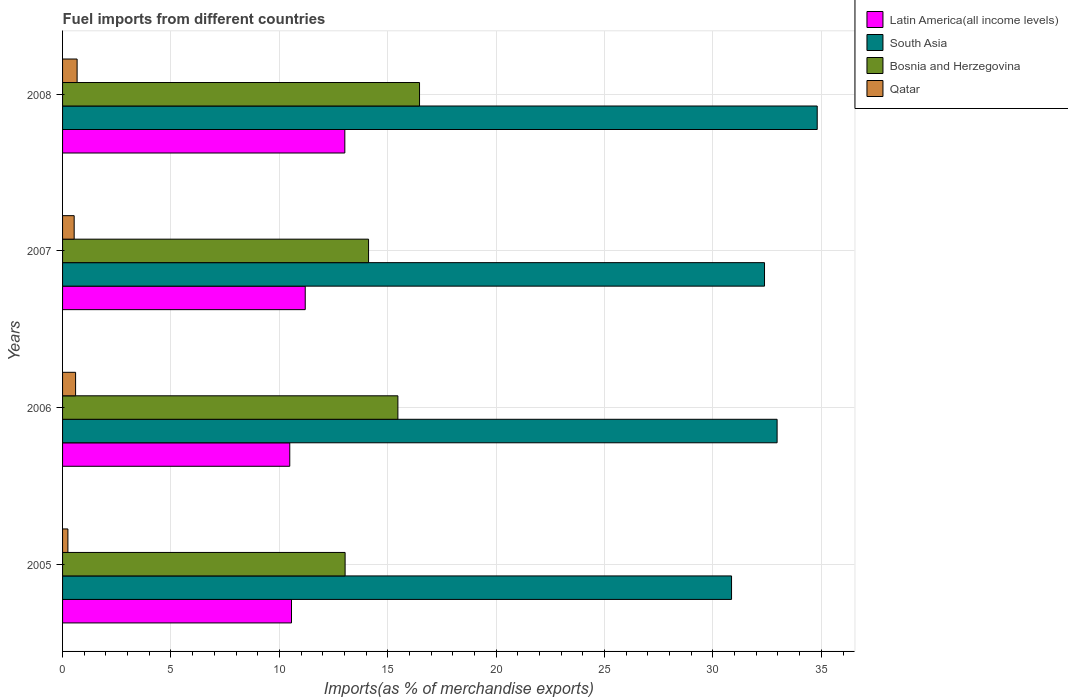Are the number of bars per tick equal to the number of legend labels?
Ensure brevity in your answer.  Yes. How many bars are there on the 3rd tick from the bottom?
Offer a very short reply. 4. What is the label of the 4th group of bars from the top?
Keep it short and to the point. 2005. What is the percentage of imports to different countries in South Asia in 2007?
Provide a short and direct response. 32.38. Across all years, what is the maximum percentage of imports to different countries in Bosnia and Herzegovina?
Your answer should be compact. 16.47. Across all years, what is the minimum percentage of imports to different countries in Qatar?
Offer a terse response. 0.25. In which year was the percentage of imports to different countries in Qatar maximum?
Provide a short and direct response. 2008. In which year was the percentage of imports to different countries in Qatar minimum?
Ensure brevity in your answer.  2005. What is the total percentage of imports to different countries in Latin America(all income levels) in the graph?
Give a very brief answer. 45.25. What is the difference between the percentage of imports to different countries in Qatar in 2005 and that in 2008?
Give a very brief answer. -0.42. What is the difference between the percentage of imports to different countries in South Asia in 2006 and the percentage of imports to different countries in Latin America(all income levels) in 2008?
Your answer should be compact. 19.94. What is the average percentage of imports to different countries in Latin America(all income levels) per year?
Offer a very short reply. 11.31. In the year 2006, what is the difference between the percentage of imports to different countries in South Asia and percentage of imports to different countries in Latin America(all income levels)?
Make the answer very short. 22.48. In how many years, is the percentage of imports to different countries in Latin America(all income levels) greater than 8 %?
Your response must be concise. 4. What is the ratio of the percentage of imports to different countries in Qatar in 2005 to that in 2007?
Provide a short and direct response. 0.46. Is the percentage of imports to different countries in Qatar in 2006 less than that in 2008?
Make the answer very short. Yes. What is the difference between the highest and the second highest percentage of imports to different countries in South Asia?
Offer a terse response. 1.85. What is the difference between the highest and the lowest percentage of imports to different countries in Bosnia and Herzegovina?
Make the answer very short. 3.43. What does the 3rd bar from the top in 2007 represents?
Offer a very short reply. South Asia. What does the 1st bar from the bottom in 2007 represents?
Offer a very short reply. Latin America(all income levels). How many bars are there?
Provide a short and direct response. 16. How many years are there in the graph?
Keep it short and to the point. 4. What is the difference between two consecutive major ticks on the X-axis?
Your answer should be compact. 5. Does the graph contain any zero values?
Keep it short and to the point. No. Does the graph contain grids?
Offer a very short reply. Yes. What is the title of the graph?
Keep it short and to the point. Fuel imports from different countries. What is the label or title of the X-axis?
Give a very brief answer. Imports(as % of merchandise exports). What is the label or title of the Y-axis?
Give a very brief answer. Years. What is the Imports(as % of merchandise exports) of Latin America(all income levels) in 2005?
Your answer should be very brief. 10.56. What is the Imports(as % of merchandise exports) in South Asia in 2005?
Your response must be concise. 30.86. What is the Imports(as % of merchandise exports) in Bosnia and Herzegovina in 2005?
Make the answer very short. 13.03. What is the Imports(as % of merchandise exports) in Qatar in 2005?
Provide a short and direct response. 0.25. What is the Imports(as % of merchandise exports) of Latin America(all income levels) in 2006?
Offer a very short reply. 10.48. What is the Imports(as % of merchandise exports) in South Asia in 2006?
Ensure brevity in your answer.  32.96. What is the Imports(as % of merchandise exports) in Bosnia and Herzegovina in 2006?
Provide a short and direct response. 15.47. What is the Imports(as % of merchandise exports) in Qatar in 2006?
Ensure brevity in your answer.  0.6. What is the Imports(as % of merchandise exports) in Latin America(all income levels) in 2007?
Keep it short and to the point. 11.19. What is the Imports(as % of merchandise exports) of South Asia in 2007?
Offer a very short reply. 32.38. What is the Imports(as % of merchandise exports) of Bosnia and Herzegovina in 2007?
Your response must be concise. 14.11. What is the Imports(as % of merchandise exports) of Qatar in 2007?
Make the answer very short. 0.54. What is the Imports(as % of merchandise exports) of Latin America(all income levels) in 2008?
Your response must be concise. 13.02. What is the Imports(as % of merchandise exports) in South Asia in 2008?
Provide a short and direct response. 34.81. What is the Imports(as % of merchandise exports) of Bosnia and Herzegovina in 2008?
Your answer should be very brief. 16.47. What is the Imports(as % of merchandise exports) of Qatar in 2008?
Your answer should be compact. 0.67. Across all years, what is the maximum Imports(as % of merchandise exports) in Latin America(all income levels)?
Provide a succinct answer. 13.02. Across all years, what is the maximum Imports(as % of merchandise exports) of South Asia?
Your answer should be very brief. 34.81. Across all years, what is the maximum Imports(as % of merchandise exports) of Bosnia and Herzegovina?
Provide a succinct answer. 16.47. Across all years, what is the maximum Imports(as % of merchandise exports) in Qatar?
Ensure brevity in your answer.  0.67. Across all years, what is the minimum Imports(as % of merchandise exports) of Latin America(all income levels)?
Your answer should be compact. 10.48. Across all years, what is the minimum Imports(as % of merchandise exports) in South Asia?
Keep it short and to the point. 30.86. Across all years, what is the minimum Imports(as % of merchandise exports) of Bosnia and Herzegovina?
Make the answer very short. 13.03. Across all years, what is the minimum Imports(as % of merchandise exports) of Qatar?
Your response must be concise. 0.25. What is the total Imports(as % of merchandise exports) of Latin America(all income levels) in the graph?
Make the answer very short. 45.25. What is the total Imports(as % of merchandise exports) of South Asia in the graph?
Offer a very short reply. 131.01. What is the total Imports(as % of merchandise exports) in Bosnia and Herzegovina in the graph?
Your answer should be compact. 59.08. What is the total Imports(as % of merchandise exports) of Qatar in the graph?
Your answer should be very brief. 2.05. What is the difference between the Imports(as % of merchandise exports) in South Asia in 2005 and that in 2006?
Your answer should be compact. -2.1. What is the difference between the Imports(as % of merchandise exports) of Bosnia and Herzegovina in 2005 and that in 2006?
Offer a terse response. -2.43. What is the difference between the Imports(as % of merchandise exports) in Qatar in 2005 and that in 2006?
Ensure brevity in your answer.  -0.35. What is the difference between the Imports(as % of merchandise exports) of Latin America(all income levels) in 2005 and that in 2007?
Your response must be concise. -0.63. What is the difference between the Imports(as % of merchandise exports) in South Asia in 2005 and that in 2007?
Keep it short and to the point. -1.52. What is the difference between the Imports(as % of merchandise exports) of Bosnia and Herzegovina in 2005 and that in 2007?
Provide a short and direct response. -1.08. What is the difference between the Imports(as % of merchandise exports) in Qatar in 2005 and that in 2007?
Your response must be concise. -0.29. What is the difference between the Imports(as % of merchandise exports) of Latin America(all income levels) in 2005 and that in 2008?
Provide a short and direct response. -2.46. What is the difference between the Imports(as % of merchandise exports) in South Asia in 2005 and that in 2008?
Ensure brevity in your answer.  -3.95. What is the difference between the Imports(as % of merchandise exports) in Bosnia and Herzegovina in 2005 and that in 2008?
Your response must be concise. -3.43. What is the difference between the Imports(as % of merchandise exports) in Qatar in 2005 and that in 2008?
Your response must be concise. -0.42. What is the difference between the Imports(as % of merchandise exports) of Latin America(all income levels) in 2006 and that in 2007?
Your answer should be compact. -0.71. What is the difference between the Imports(as % of merchandise exports) of South Asia in 2006 and that in 2007?
Your answer should be very brief. 0.58. What is the difference between the Imports(as % of merchandise exports) of Bosnia and Herzegovina in 2006 and that in 2007?
Offer a very short reply. 1.35. What is the difference between the Imports(as % of merchandise exports) of Qatar in 2006 and that in 2007?
Your answer should be compact. 0.07. What is the difference between the Imports(as % of merchandise exports) in Latin America(all income levels) in 2006 and that in 2008?
Your answer should be compact. -2.54. What is the difference between the Imports(as % of merchandise exports) in South Asia in 2006 and that in 2008?
Keep it short and to the point. -1.85. What is the difference between the Imports(as % of merchandise exports) in Bosnia and Herzegovina in 2006 and that in 2008?
Your answer should be compact. -1. What is the difference between the Imports(as % of merchandise exports) in Qatar in 2006 and that in 2008?
Keep it short and to the point. -0.07. What is the difference between the Imports(as % of merchandise exports) in Latin America(all income levels) in 2007 and that in 2008?
Your answer should be very brief. -1.83. What is the difference between the Imports(as % of merchandise exports) of South Asia in 2007 and that in 2008?
Offer a terse response. -2.43. What is the difference between the Imports(as % of merchandise exports) of Bosnia and Herzegovina in 2007 and that in 2008?
Keep it short and to the point. -2.35. What is the difference between the Imports(as % of merchandise exports) in Qatar in 2007 and that in 2008?
Your response must be concise. -0.14. What is the difference between the Imports(as % of merchandise exports) of Latin America(all income levels) in 2005 and the Imports(as % of merchandise exports) of South Asia in 2006?
Give a very brief answer. -22.4. What is the difference between the Imports(as % of merchandise exports) in Latin America(all income levels) in 2005 and the Imports(as % of merchandise exports) in Bosnia and Herzegovina in 2006?
Provide a succinct answer. -4.91. What is the difference between the Imports(as % of merchandise exports) of Latin America(all income levels) in 2005 and the Imports(as % of merchandise exports) of Qatar in 2006?
Your answer should be compact. 9.96. What is the difference between the Imports(as % of merchandise exports) in South Asia in 2005 and the Imports(as % of merchandise exports) in Bosnia and Herzegovina in 2006?
Provide a short and direct response. 15.39. What is the difference between the Imports(as % of merchandise exports) of South Asia in 2005 and the Imports(as % of merchandise exports) of Qatar in 2006?
Your answer should be very brief. 30.26. What is the difference between the Imports(as % of merchandise exports) of Bosnia and Herzegovina in 2005 and the Imports(as % of merchandise exports) of Qatar in 2006?
Provide a short and direct response. 12.43. What is the difference between the Imports(as % of merchandise exports) of Latin America(all income levels) in 2005 and the Imports(as % of merchandise exports) of South Asia in 2007?
Ensure brevity in your answer.  -21.82. What is the difference between the Imports(as % of merchandise exports) of Latin America(all income levels) in 2005 and the Imports(as % of merchandise exports) of Bosnia and Herzegovina in 2007?
Provide a succinct answer. -3.55. What is the difference between the Imports(as % of merchandise exports) of Latin America(all income levels) in 2005 and the Imports(as % of merchandise exports) of Qatar in 2007?
Offer a terse response. 10.02. What is the difference between the Imports(as % of merchandise exports) in South Asia in 2005 and the Imports(as % of merchandise exports) in Bosnia and Herzegovina in 2007?
Keep it short and to the point. 16.74. What is the difference between the Imports(as % of merchandise exports) in South Asia in 2005 and the Imports(as % of merchandise exports) in Qatar in 2007?
Your response must be concise. 30.32. What is the difference between the Imports(as % of merchandise exports) of Bosnia and Herzegovina in 2005 and the Imports(as % of merchandise exports) of Qatar in 2007?
Provide a short and direct response. 12.5. What is the difference between the Imports(as % of merchandise exports) in Latin America(all income levels) in 2005 and the Imports(as % of merchandise exports) in South Asia in 2008?
Your response must be concise. -24.25. What is the difference between the Imports(as % of merchandise exports) in Latin America(all income levels) in 2005 and the Imports(as % of merchandise exports) in Bosnia and Herzegovina in 2008?
Offer a terse response. -5.91. What is the difference between the Imports(as % of merchandise exports) in Latin America(all income levels) in 2005 and the Imports(as % of merchandise exports) in Qatar in 2008?
Give a very brief answer. 9.89. What is the difference between the Imports(as % of merchandise exports) of South Asia in 2005 and the Imports(as % of merchandise exports) of Bosnia and Herzegovina in 2008?
Keep it short and to the point. 14.39. What is the difference between the Imports(as % of merchandise exports) of South Asia in 2005 and the Imports(as % of merchandise exports) of Qatar in 2008?
Offer a terse response. 30.19. What is the difference between the Imports(as % of merchandise exports) of Bosnia and Herzegovina in 2005 and the Imports(as % of merchandise exports) of Qatar in 2008?
Offer a very short reply. 12.36. What is the difference between the Imports(as % of merchandise exports) in Latin America(all income levels) in 2006 and the Imports(as % of merchandise exports) in South Asia in 2007?
Keep it short and to the point. -21.9. What is the difference between the Imports(as % of merchandise exports) in Latin America(all income levels) in 2006 and the Imports(as % of merchandise exports) in Bosnia and Herzegovina in 2007?
Ensure brevity in your answer.  -3.63. What is the difference between the Imports(as % of merchandise exports) in Latin America(all income levels) in 2006 and the Imports(as % of merchandise exports) in Qatar in 2007?
Your answer should be very brief. 9.94. What is the difference between the Imports(as % of merchandise exports) of South Asia in 2006 and the Imports(as % of merchandise exports) of Bosnia and Herzegovina in 2007?
Make the answer very short. 18.85. What is the difference between the Imports(as % of merchandise exports) of South Asia in 2006 and the Imports(as % of merchandise exports) of Qatar in 2007?
Your answer should be compact. 32.42. What is the difference between the Imports(as % of merchandise exports) in Bosnia and Herzegovina in 2006 and the Imports(as % of merchandise exports) in Qatar in 2007?
Keep it short and to the point. 14.93. What is the difference between the Imports(as % of merchandise exports) in Latin America(all income levels) in 2006 and the Imports(as % of merchandise exports) in South Asia in 2008?
Ensure brevity in your answer.  -24.33. What is the difference between the Imports(as % of merchandise exports) of Latin America(all income levels) in 2006 and the Imports(as % of merchandise exports) of Bosnia and Herzegovina in 2008?
Your answer should be very brief. -5.99. What is the difference between the Imports(as % of merchandise exports) of Latin America(all income levels) in 2006 and the Imports(as % of merchandise exports) of Qatar in 2008?
Ensure brevity in your answer.  9.81. What is the difference between the Imports(as % of merchandise exports) in South Asia in 2006 and the Imports(as % of merchandise exports) in Bosnia and Herzegovina in 2008?
Give a very brief answer. 16.49. What is the difference between the Imports(as % of merchandise exports) in South Asia in 2006 and the Imports(as % of merchandise exports) in Qatar in 2008?
Provide a succinct answer. 32.29. What is the difference between the Imports(as % of merchandise exports) in Bosnia and Herzegovina in 2006 and the Imports(as % of merchandise exports) in Qatar in 2008?
Offer a terse response. 14.8. What is the difference between the Imports(as % of merchandise exports) of Latin America(all income levels) in 2007 and the Imports(as % of merchandise exports) of South Asia in 2008?
Give a very brief answer. -23.62. What is the difference between the Imports(as % of merchandise exports) of Latin America(all income levels) in 2007 and the Imports(as % of merchandise exports) of Bosnia and Herzegovina in 2008?
Your answer should be very brief. -5.27. What is the difference between the Imports(as % of merchandise exports) of Latin America(all income levels) in 2007 and the Imports(as % of merchandise exports) of Qatar in 2008?
Give a very brief answer. 10.52. What is the difference between the Imports(as % of merchandise exports) in South Asia in 2007 and the Imports(as % of merchandise exports) in Bosnia and Herzegovina in 2008?
Provide a short and direct response. 15.91. What is the difference between the Imports(as % of merchandise exports) in South Asia in 2007 and the Imports(as % of merchandise exports) in Qatar in 2008?
Provide a succinct answer. 31.71. What is the difference between the Imports(as % of merchandise exports) in Bosnia and Herzegovina in 2007 and the Imports(as % of merchandise exports) in Qatar in 2008?
Your answer should be compact. 13.44. What is the average Imports(as % of merchandise exports) in Latin America(all income levels) per year?
Your response must be concise. 11.31. What is the average Imports(as % of merchandise exports) in South Asia per year?
Ensure brevity in your answer.  32.75. What is the average Imports(as % of merchandise exports) of Bosnia and Herzegovina per year?
Give a very brief answer. 14.77. What is the average Imports(as % of merchandise exports) of Qatar per year?
Keep it short and to the point. 0.51. In the year 2005, what is the difference between the Imports(as % of merchandise exports) of Latin America(all income levels) and Imports(as % of merchandise exports) of South Asia?
Offer a very short reply. -20.3. In the year 2005, what is the difference between the Imports(as % of merchandise exports) in Latin America(all income levels) and Imports(as % of merchandise exports) in Bosnia and Herzegovina?
Your answer should be compact. -2.47. In the year 2005, what is the difference between the Imports(as % of merchandise exports) in Latin America(all income levels) and Imports(as % of merchandise exports) in Qatar?
Offer a very short reply. 10.31. In the year 2005, what is the difference between the Imports(as % of merchandise exports) in South Asia and Imports(as % of merchandise exports) in Bosnia and Herzegovina?
Provide a succinct answer. 17.82. In the year 2005, what is the difference between the Imports(as % of merchandise exports) in South Asia and Imports(as % of merchandise exports) in Qatar?
Offer a terse response. 30.61. In the year 2005, what is the difference between the Imports(as % of merchandise exports) of Bosnia and Herzegovina and Imports(as % of merchandise exports) of Qatar?
Provide a short and direct response. 12.79. In the year 2006, what is the difference between the Imports(as % of merchandise exports) in Latin America(all income levels) and Imports(as % of merchandise exports) in South Asia?
Offer a terse response. -22.48. In the year 2006, what is the difference between the Imports(as % of merchandise exports) of Latin America(all income levels) and Imports(as % of merchandise exports) of Bosnia and Herzegovina?
Offer a terse response. -4.99. In the year 2006, what is the difference between the Imports(as % of merchandise exports) of Latin America(all income levels) and Imports(as % of merchandise exports) of Qatar?
Make the answer very short. 9.88. In the year 2006, what is the difference between the Imports(as % of merchandise exports) in South Asia and Imports(as % of merchandise exports) in Bosnia and Herzegovina?
Offer a very short reply. 17.49. In the year 2006, what is the difference between the Imports(as % of merchandise exports) in South Asia and Imports(as % of merchandise exports) in Qatar?
Provide a succinct answer. 32.36. In the year 2006, what is the difference between the Imports(as % of merchandise exports) in Bosnia and Herzegovina and Imports(as % of merchandise exports) in Qatar?
Give a very brief answer. 14.87. In the year 2007, what is the difference between the Imports(as % of merchandise exports) in Latin America(all income levels) and Imports(as % of merchandise exports) in South Asia?
Provide a short and direct response. -21.19. In the year 2007, what is the difference between the Imports(as % of merchandise exports) in Latin America(all income levels) and Imports(as % of merchandise exports) in Bosnia and Herzegovina?
Provide a short and direct response. -2.92. In the year 2007, what is the difference between the Imports(as % of merchandise exports) in Latin America(all income levels) and Imports(as % of merchandise exports) in Qatar?
Give a very brief answer. 10.66. In the year 2007, what is the difference between the Imports(as % of merchandise exports) in South Asia and Imports(as % of merchandise exports) in Bosnia and Herzegovina?
Give a very brief answer. 18.26. In the year 2007, what is the difference between the Imports(as % of merchandise exports) in South Asia and Imports(as % of merchandise exports) in Qatar?
Your answer should be compact. 31.84. In the year 2007, what is the difference between the Imports(as % of merchandise exports) in Bosnia and Herzegovina and Imports(as % of merchandise exports) in Qatar?
Offer a very short reply. 13.58. In the year 2008, what is the difference between the Imports(as % of merchandise exports) in Latin America(all income levels) and Imports(as % of merchandise exports) in South Asia?
Keep it short and to the point. -21.79. In the year 2008, what is the difference between the Imports(as % of merchandise exports) of Latin America(all income levels) and Imports(as % of merchandise exports) of Bosnia and Herzegovina?
Your answer should be very brief. -3.45. In the year 2008, what is the difference between the Imports(as % of merchandise exports) of Latin America(all income levels) and Imports(as % of merchandise exports) of Qatar?
Keep it short and to the point. 12.35. In the year 2008, what is the difference between the Imports(as % of merchandise exports) of South Asia and Imports(as % of merchandise exports) of Bosnia and Herzegovina?
Offer a terse response. 18.34. In the year 2008, what is the difference between the Imports(as % of merchandise exports) in South Asia and Imports(as % of merchandise exports) in Qatar?
Ensure brevity in your answer.  34.14. In the year 2008, what is the difference between the Imports(as % of merchandise exports) in Bosnia and Herzegovina and Imports(as % of merchandise exports) in Qatar?
Make the answer very short. 15.8. What is the ratio of the Imports(as % of merchandise exports) of Latin America(all income levels) in 2005 to that in 2006?
Provide a succinct answer. 1.01. What is the ratio of the Imports(as % of merchandise exports) in South Asia in 2005 to that in 2006?
Your response must be concise. 0.94. What is the ratio of the Imports(as % of merchandise exports) in Bosnia and Herzegovina in 2005 to that in 2006?
Provide a succinct answer. 0.84. What is the ratio of the Imports(as % of merchandise exports) of Qatar in 2005 to that in 2006?
Your response must be concise. 0.41. What is the ratio of the Imports(as % of merchandise exports) of Latin America(all income levels) in 2005 to that in 2007?
Provide a short and direct response. 0.94. What is the ratio of the Imports(as % of merchandise exports) in South Asia in 2005 to that in 2007?
Ensure brevity in your answer.  0.95. What is the ratio of the Imports(as % of merchandise exports) in Bosnia and Herzegovina in 2005 to that in 2007?
Ensure brevity in your answer.  0.92. What is the ratio of the Imports(as % of merchandise exports) in Qatar in 2005 to that in 2007?
Keep it short and to the point. 0.46. What is the ratio of the Imports(as % of merchandise exports) in Latin America(all income levels) in 2005 to that in 2008?
Give a very brief answer. 0.81. What is the ratio of the Imports(as % of merchandise exports) in South Asia in 2005 to that in 2008?
Make the answer very short. 0.89. What is the ratio of the Imports(as % of merchandise exports) of Bosnia and Herzegovina in 2005 to that in 2008?
Your answer should be very brief. 0.79. What is the ratio of the Imports(as % of merchandise exports) of Qatar in 2005 to that in 2008?
Give a very brief answer. 0.37. What is the ratio of the Imports(as % of merchandise exports) of Latin America(all income levels) in 2006 to that in 2007?
Provide a short and direct response. 0.94. What is the ratio of the Imports(as % of merchandise exports) of South Asia in 2006 to that in 2007?
Your response must be concise. 1.02. What is the ratio of the Imports(as % of merchandise exports) of Bosnia and Herzegovina in 2006 to that in 2007?
Your answer should be compact. 1.1. What is the ratio of the Imports(as % of merchandise exports) in Qatar in 2006 to that in 2007?
Your answer should be very brief. 1.12. What is the ratio of the Imports(as % of merchandise exports) of Latin America(all income levels) in 2006 to that in 2008?
Provide a succinct answer. 0.8. What is the ratio of the Imports(as % of merchandise exports) in South Asia in 2006 to that in 2008?
Ensure brevity in your answer.  0.95. What is the ratio of the Imports(as % of merchandise exports) of Bosnia and Herzegovina in 2006 to that in 2008?
Ensure brevity in your answer.  0.94. What is the ratio of the Imports(as % of merchandise exports) of Qatar in 2006 to that in 2008?
Your answer should be compact. 0.9. What is the ratio of the Imports(as % of merchandise exports) of Latin America(all income levels) in 2007 to that in 2008?
Make the answer very short. 0.86. What is the ratio of the Imports(as % of merchandise exports) of South Asia in 2007 to that in 2008?
Keep it short and to the point. 0.93. What is the ratio of the Imports(as % of merchandise exports) of Bosnia and Herzegovina in 2007 to that in 2008?
Make the answer very short. 0.86. What is the ratio of the Imports(as % of merchandise exports) in Qatar in 2007 to that in 2008?
Give a very brief answer. 0.8. What is the difference between the highest and the second highest Imports(as % of merchandise exports) of Latin America(all income levels)?
Your response must be concise. 1.83. What is the difference between the highest and the second highest Imports(as % of merchandise exports) of South Asia?
Offer a terse response. 1.85. What is the difference between the highest and the second highest Imports(as % of merchandise exports) of Bosnia and Herzegovina?
Provide a short and direct response. 1. What is the difference between the highest and the second highest Imports(as % of merchandise exports) in Qatar?
Make the answer very short. 0.07. What is the difference between the highest and the lowest Imports(as % of merchandise exports) of Latin America(all income levels)?
Your answer should be very brief. 2.54. What is the difference between the highest and the lowest Imports(as % of merchandise exports) of South Asia?
Provide a succinct answer. 3.95. What is the difference between the highest and the lowest Imports(as % of merchandise exports) of Bosnia and Herzegovina?
Your answer should be very brief. 3.43. What is the difference between the highest and the lowest Imports(as % of merchandise exports) in Qatar?
Your answer should be very brief. 0.42. 